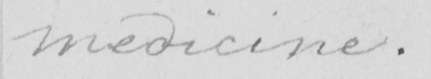Transcribe the text shown in this historical manuscript line. medicine . 